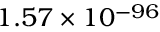<formula> <loc_0><loc_0><loc_500><loc_500>1 . 5 7 \times 1 0 ^ { - 9 6 }</formula> 